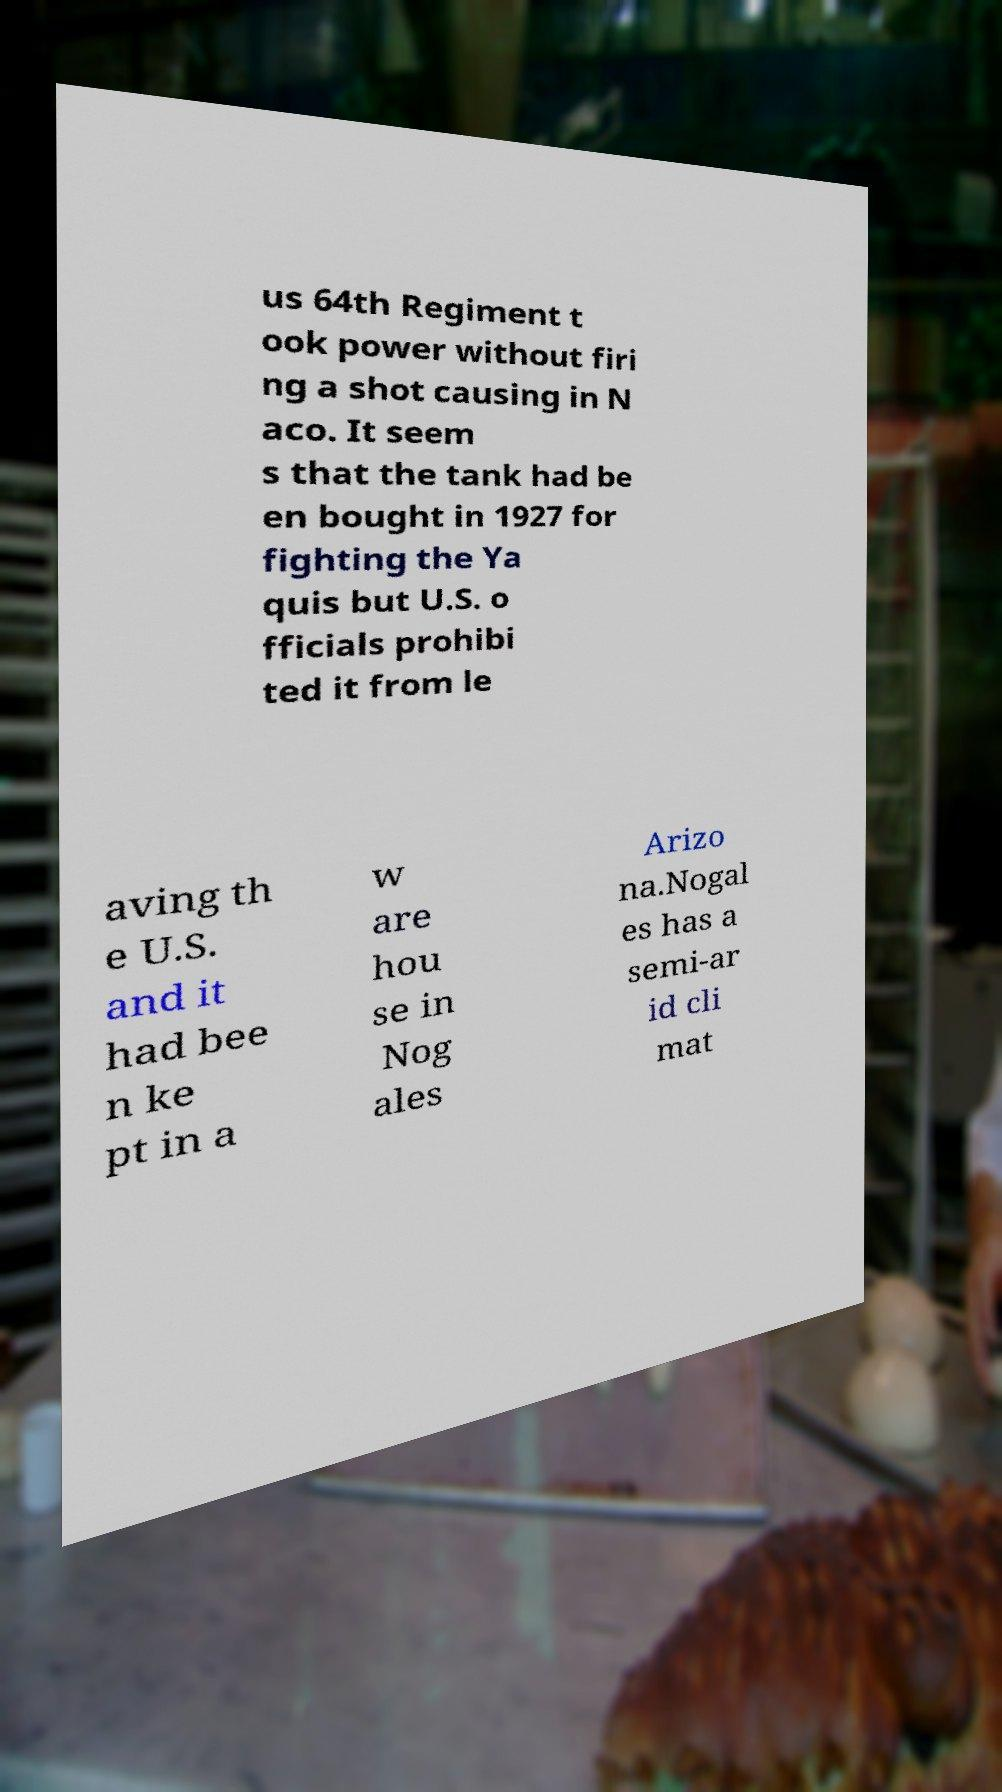Can you accurately transcribe the text from the provided image for me? us 64th Regiment t ook power without firi ng a shot causing in N aco. It seem s that the tank had be en bought in 1927 for fighting the Ya quis but U.S. o fficials prohibi ted it from le aving th e U.S. and it had bee n ke pt in a w are hou se in Nog ales Arizo na.Nogal es has a semi-ar id cli mat 